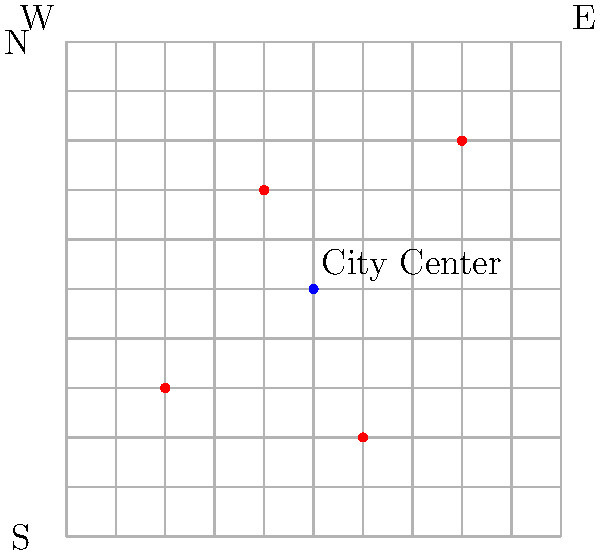As a breast cancer awareness advocate, you're mapping support centers in a city using a 10x10 grid system. The city center is located at coordinates (5,5). Four support centers are marked on the map at (2,3), (4,7), (6,2), and (8,8). Which support center is closest to the city center, and what is its Manhattan distance from the center? To solve this problem, we need to follow these steps:

1. Understand Manhattan distance:
   Manhattan distance is the sum of the absolute differences of the x and y coordinates.
   For points $(x_1, y_1)$ and $(x_2, y_2)$, the Manhattan distance is:
   $|x_1 - x_2| + |y_1 - y_2|$

2. Calculate the Manhattan distance for each support center from the city center (5,5):

   a) For (2,3):
      $|2 - 5| + |3 - 5| = 3 + 2 = 5$

   b) For (4,7):
      $|4 - 5| + |7 - 5| = 1 + 2 = 3$

   c) For (6,2):
      $|6 - 5| + |2 - 5| = 1 + 3 = 4$

   d) For (8,8):
      $|8 - 5| + |8 - 5| = 3 + 3 = 6$

3. Compare the distances:
   The smallest distance is 3, corresponding to the support center at (4,7).

Therefore, the support center closest to the city center is at (4,7), with a Manhattan distance of 3 units.
Answer: (4,7), 3 units 